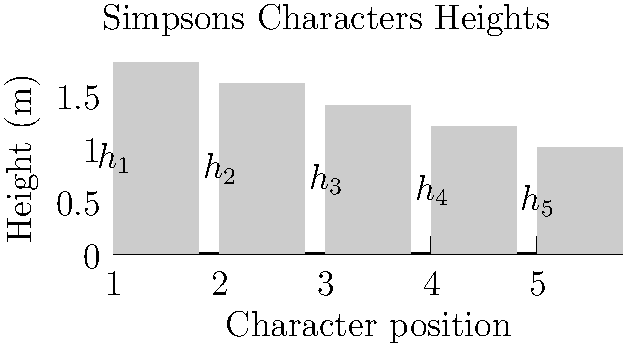You're arranging The Simpsons characters for a group photo. The heights of five characters (in meters) are shown in the graph. To create a visually appealing composition, you want to minimize the difference between the heights of adjacent characters. What is the optimal arrangement of characters to achieve this, and what is the sum of the differences between adjacent characters' heights in this arrangement? To solve this optimization problem, we'll follow these steps:

1) First, let's identify the heights:
   $h_1 = 1.8m$, $h_2 = 1.6m$, $h_3 = 1.4m$, $h_4 = 1.2m$, $h_5 = 1.0m$

2) To minimize the difference between adjacent characters, we should arrange them in descending or ascending order of height. Let's choose descending order.

3) The optimal arrangement is: $1.8m, 1.6m, 1.4m, 1.2m, 1.0m$

4) Now, let's calculate the differences between adjacent characters:
   $(1.8m - 1.6m) + (1.6m - 1.4m) + (1.4m - 1.2m) + (1.2m - 1.0m)$

5) Simplifying:
   $0.2m + 0.2m + 0.2m + 0.2m = 0.8m$

Therefore, the optimal arrangement is from tallest to shortest, and the sum of the differences between adjacent characters' heights is 0.8m.
Answer: Tallest to shortest; 0.8m 